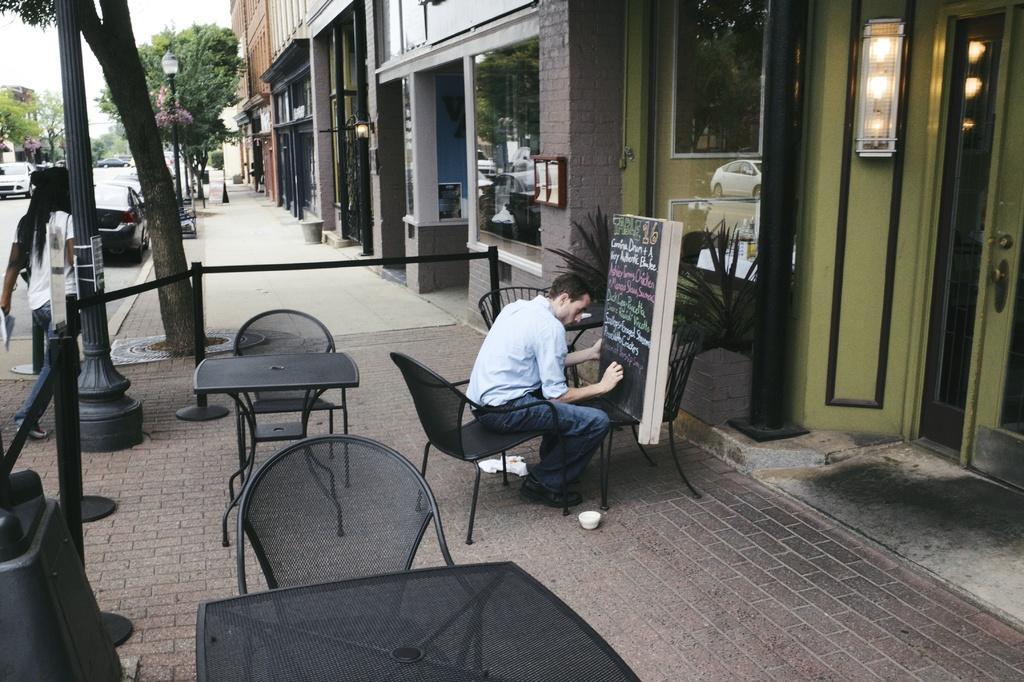Please provide a concise description of this image. In this picture there is a man sitting in the chair and writing something on the black board in front of a building. There is some tables and chairs behind him. In the background there is a car, street light pole and some trees. There are some buildings and a sky here. 